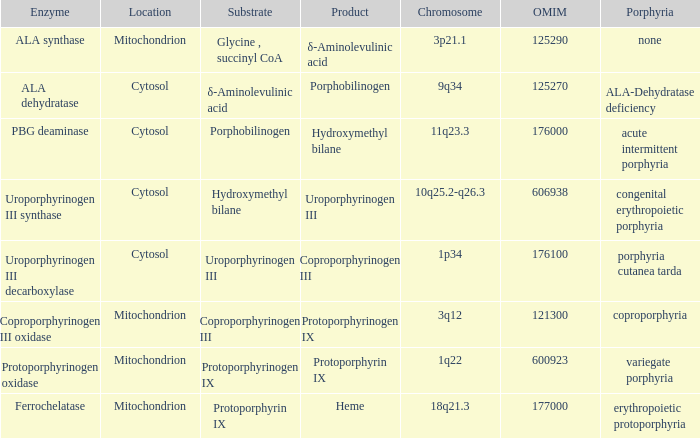What is the location of the enzyme Uroporphyrinogen iii Synthase? Cytosol. 